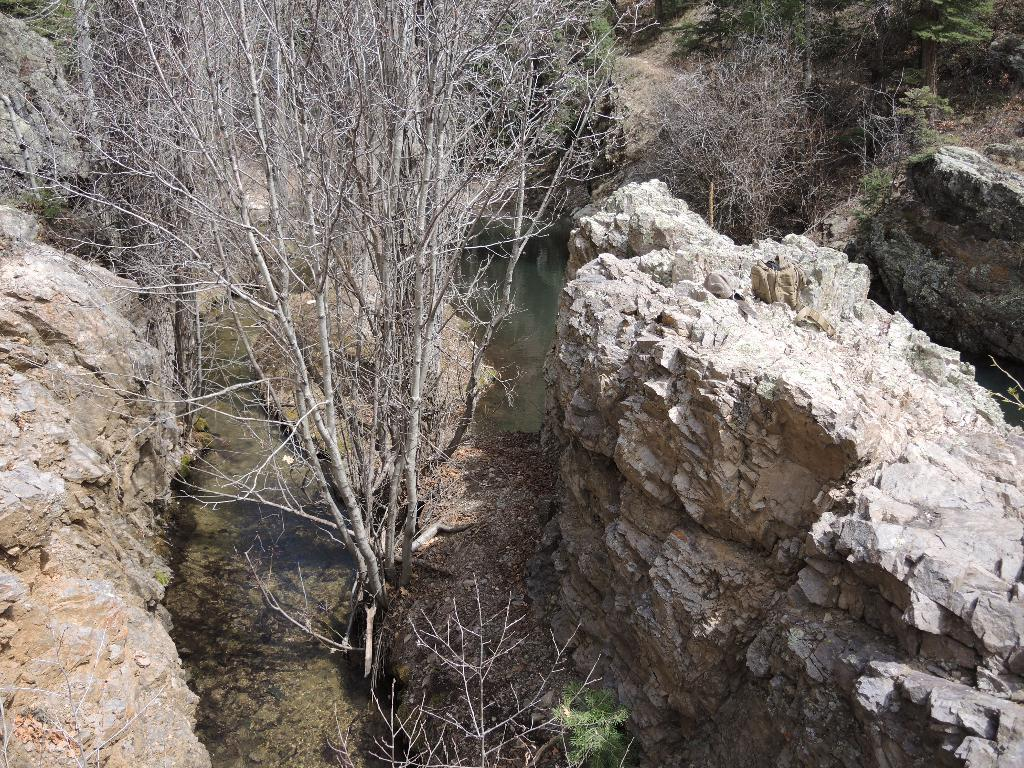What type of natural elements can be seen in the image? There are rocks in the image. What type of vegetation is present in the image? There are dried plants in the image. What type of example is being used in the image? There is no example present in the image; it features rocks and dried plants. What type of trade is being conducted in the image? There is no trade being conducted in the image; it features rocks and dried plants. 